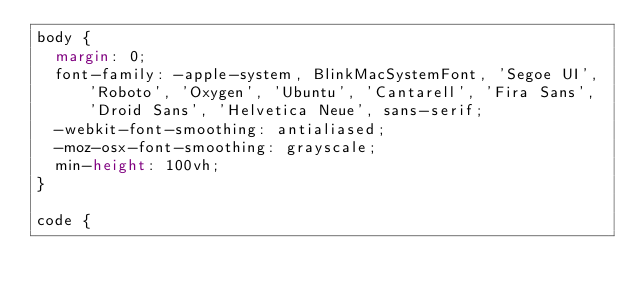<code> <loc_0><loc_0><loc_500><loc_500><_CSS_>body {
	margin: 0;
	font-family: -apple-system, BlinkMacSystemFont, 'Segoe UI', 'Roboto', 'Oxygen', 'Ubuntu', 'Cantarell', 'Fira Sans', 'Droid Sans', 'Helvetica Neue', sans-serif;
	-webkit-font-smoothing: antialiased;
	-moz-osx-font-smoothing: grayscale;
	min-height: 100vh;
}

code {</code> 